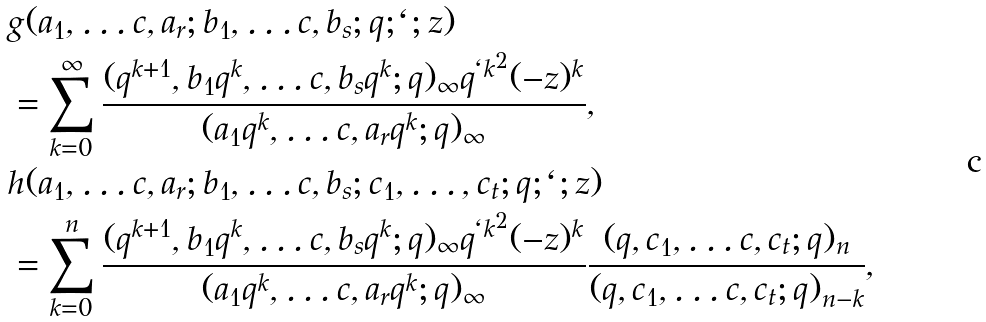<formula> <loc_0><loc_0><loc_500><loc_500>& g ( a _ { 1 } , \dots c , a _ { r } ; b _ { 1 } , \dots c , b _ { s } ; q ; \ell ; z ) \\ & = \sum _ { k = 0 } ^ { \infty } \frac { ( q ^ { k + 1 } , b _ { 1 } q ^ { k } , \dots c , b _ { s } q ^ { k } ; q ) _ { \infty } q ^ { \ell k ^ { 2 } } ( - z ) ^ { k } } { ( a _ { 1 } q ^ { k } , \dots c , a _ { r } q ^ { k } ; q ) _ { \infty } } , \\ & h ( a _ { 1 } , \dots c , a _ { r } ; b _ { 1 } , \dots c , b _ { s } ; c _ { 1 } , \dots , c _ { t } ; q ; \ell ; z ) \\ & = \sum _ { k = 0 } ^ { n } \frac { ( q ^ { k + 1 } , b _ { 1 } q ^ { k } , \dots c , b _ { s } q ^ { k } ; q ) _ { \infty } q ^ { \ell k ^ { 2 } } ( - z ) ^ { k } } { ( a _ { 1 } q ^ { k } , \dots c , a _ { r } q ^ { k } ; q ) _ { \infty } } \frac { ( q , c _ { 1 } , \dots c , c _ { t } ; q ) _ { n } } { ( q , c _ { 1 } , \dots c , c _ { t } ; q ) _ { n - k } } ,</formula> 